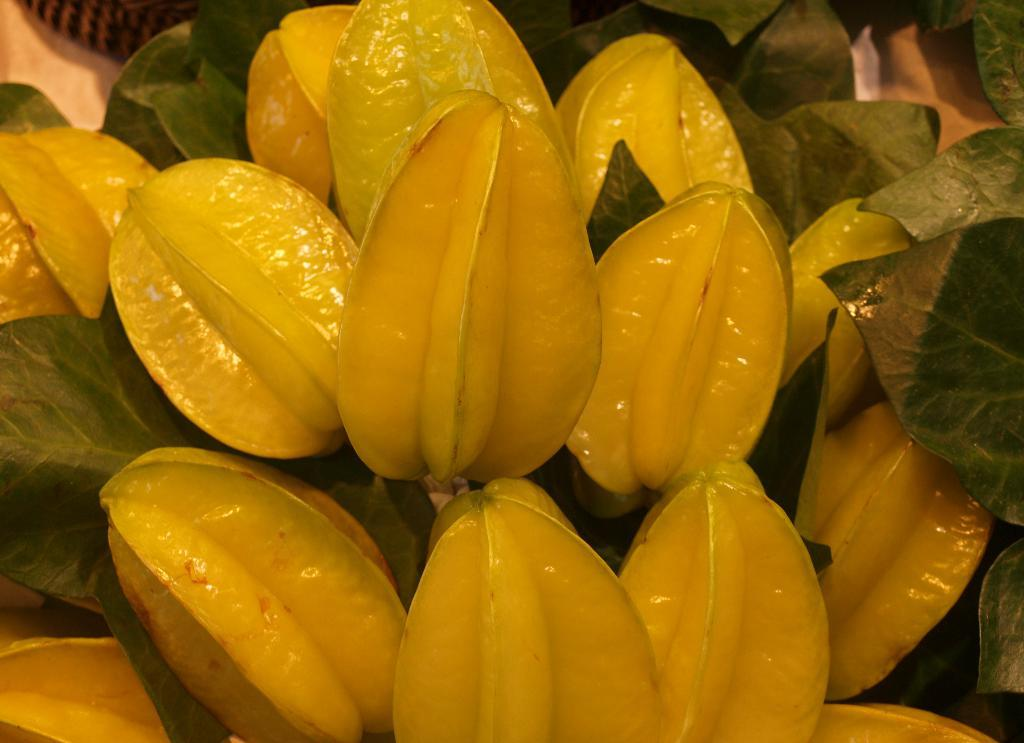What type of fruit is present in the image? The image contains star fruits. Are there any additional features visible on the star fruits? Yes, the star fruits have leaves. Who is the expert on star fruits in the image? There is no expert on star fruits present in the image, as it is a still image and does not depict people. 